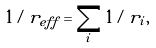<formula> <loc_0><loc_0><loc_500><loc_500>1 / r _ { e f f } = \sum _ { i } 1 / r _ { i } ,</formula> 